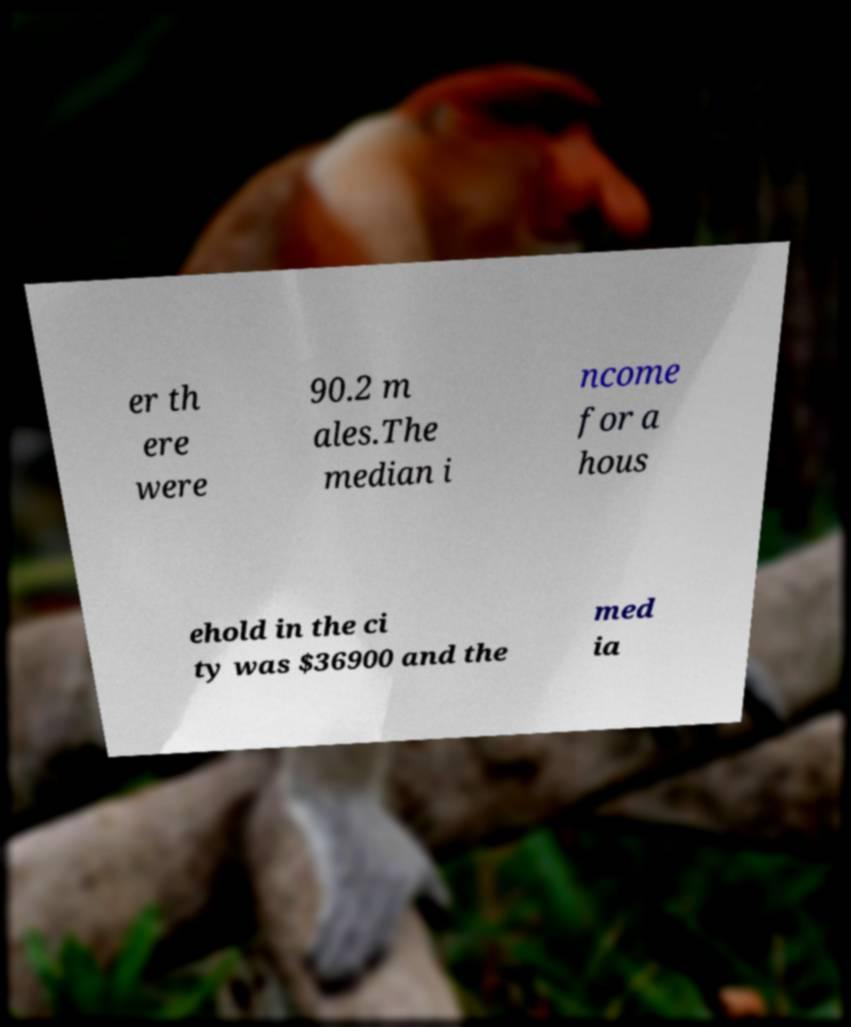Could you assist in decoding the text presented in this image and type it out clearly? er th ere were 90.2 m ales.The median i ncome for a hous ehold in the ci ty was $36900 and the med ia 